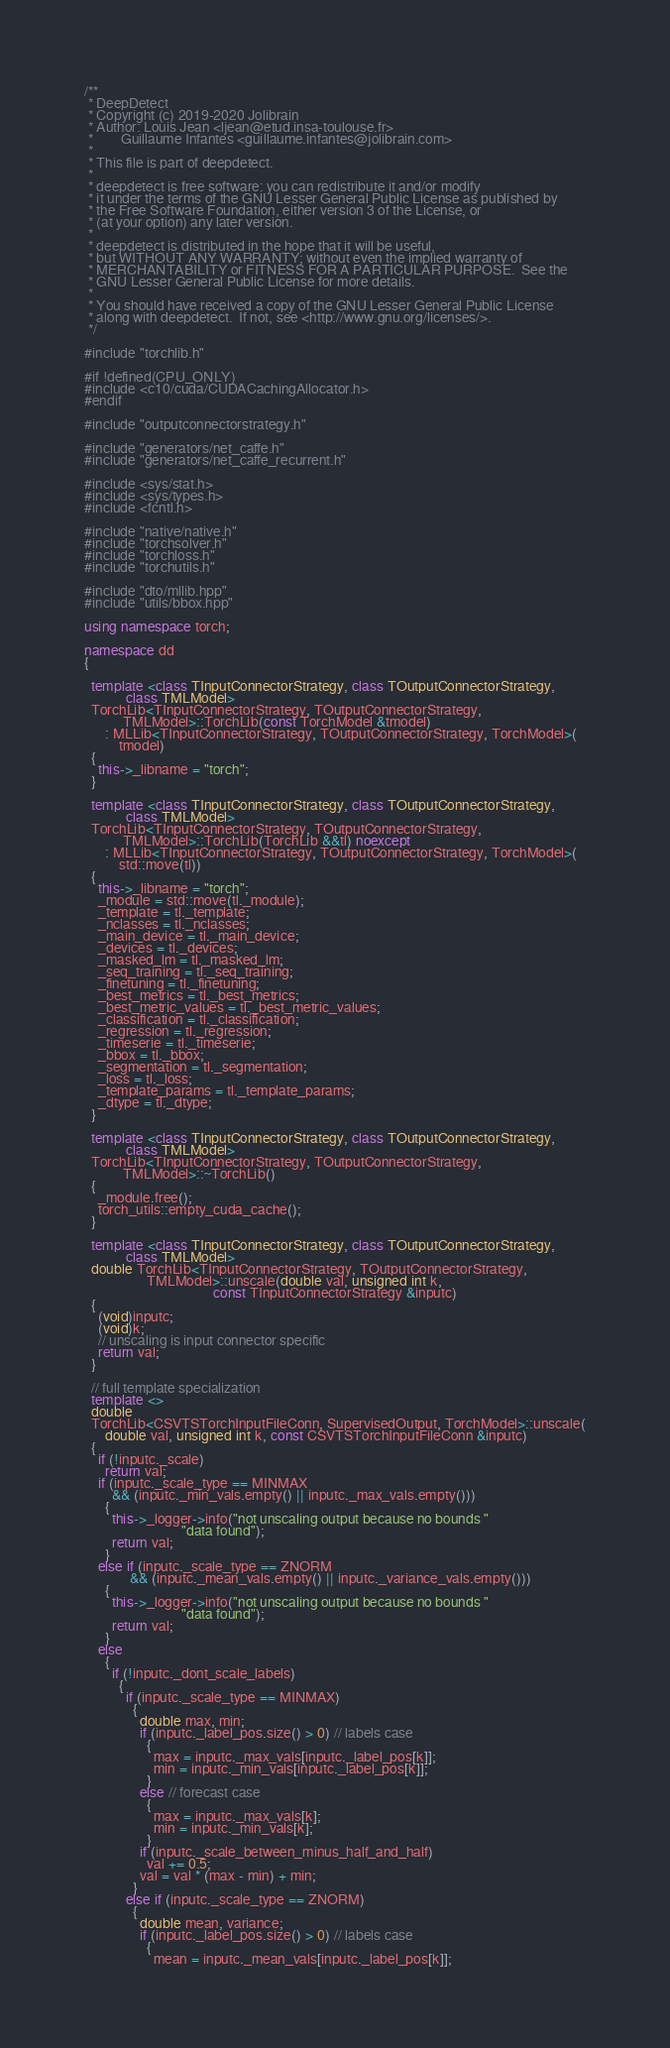Convert code to text. <code><loc_0><loc_0><loc_500><loc_500><_C++_>/**
 * DeepDetect
 * Copyright (c) 2019-2020 Jolibrain
 * Author: Louis Jean <ljean@etud.insa-toulouse.fr>
 *        Guillaume Infantes <guillaume.infantes@jolibrain.com>
 *
 * This file is part of deepdetect.
 *
 * deepdetect is free software: you can redistribute it and/or modify
 * it under the terms of the GNU Lesser General Public License as published by
 * the Free Software Foundation, either version 3 of the License, or
 * (at your option) any later version.
 *
 * deepdetect is distributed in the hope that it will be useful,
 * but WITHOUT ANY WARRANTY; without even the implied warranty of
 * MERCHANTABILITY or FITNESS FOR A PARTICULAR PURPOSE.  See the
 * GNU Lesser General Public License for more details.
 *
 * You should have received a copy of the GNU Lesser General Public License
 * along with deepdetect.  If not, see <http://www.gnu.org/licenses/>.
 */

#include "torchlib.h"

#if !defined(CPU_ONLY)
#include <c10/cuda/CUDACachingAllocator.h>
#endif

#include "outputconnectorstrategy.h"

#include "generators/net_caffe.h"
#include "generators/net_caffe_recurrent.h"

#include <sys/stat.h>
#include <sys/types.h>
#include <fcntl.h>

#include "native/native.h"
#include "torchsolver.h"
#include "torchloss.h"
#include "torchutils.h"

#include "dto/mllib.hpp"
#include "utils/bbox.hpp"

using namespace torch;

namespace dd
{

  template <class TInputConnectorStrategy, class TOutputConnectorStrategy,
            class TMLModel>
  TorchLib<TInputConnectorStrategy, TOutputConnectorStrategy,
           TMLModel>::TorchLib(const TorchModel &tmodel)
      : MLLib<TInputConnectorStrategy, TOutputConnectorStrategy, TorchModel>(
          tmodel)
  {
    this->_libname = "torch";
  }

  template <class TInputConnectorStrategy, class TOutputConnectorStrategy,
            class TMLModel>
  TorchLib<TInputConnectorStrategy, TOutputConnectorStrategy,
           TMLModel>::TorchLib(TorchLib &&tl) noexcept
      : MLLib<TInputConnectorStrategy, TOutputConnectorStrategy, TorchModel>(
          std::move(tl))
  {
    this->_libname = "torch";
    _module = std::move(tl._module);
    _template = tl._template;
    _nclasses = tl._nclasses;
    _main_device = tl._main_device;
    _devices = tl._devices;
    _masked_lm = tl._masked_lm;
    _seq_training = tl._seq_training;
    _finetuning = tl._finetuning;
    _best_metrics = tl._best_metrics;
    _best_metric_values = tl._best_metric_values;
    _classification = tl._classification;
    _regression = tl._regression;
    _timeserie = tl._timeserie;
    _bbox = tl._bbox;
    _segmentation = tl._segmentation;
    _loss = tl._loss;
    _template_params = tl._template_params;
    _dtype = tl._dtype;
  }

  template <class TInputConnectorStrategy, class TOutputConnectorStrategy,
            class TMLModel>
  TorchLib<TInputConnectorStrategy, TOutputConnectorStrategy,
           TMLModel>::~TorchLib()
  {
    _module.free();
    torch_utils::empty_cuda_cache();
  }

  template <class TInputConnectorStrategy, class TOutputConnectorStrategy,
            class TMLModel>
  double TorchLib<TInputConnectorStrategy, TOutputConnectorStrategy,
                  TMLModel>::unscale(double val, unsigned int k,
                                     const TInputConnectorStrategy &inputc)
  {
    (void)inputc;
    (void)k;
    // unscaling is input connector specific
    return val;
  }

  // full template specialization
  template <>
  double
  TorchLib<CSVTSTorchInputFileConn, SupervisedOutput, TorchModel>::unscale(
      double val, unsigned int k, const CSVTSTorchInputFileConn &inputc)
  {
    if (!inputc._scale)
      return val;
    if (inputc._scale_type == MINMAX
        && (inputc._min_vals.empty() || inputc._max_vals.empty()))
      {
        this->_logger->info("not unscaling output because no bounds "
                            "data found");
        return val;
      }
    else if (inputc._scale_type == ZNORM
             && (inputc._mean_vals.empty() || inputc._variance_vals.empty()))
      {
        this->_logger->info("not unscaling output because no bounds "
                            "data found");
        return val;
      }
    else
      {
        if (!inputc._dont_scale_labels)
          {
            if (inputc._scale_type == MINMAX)
              {
                double max, min;
                if (inputc._label_pos.size() > 0) // labels case
                  {
                    max = inputc._max_vals[inputc._label_pos[k]];
                    min = inputc._min_vals[inputc._label_pos[k]];
                  }
                else // forecast case
                  {
                    max = inputc._max_vals[k];
                    min = inputc._min_vals[k];
                  }
                if (inputc._scale_between_minus_half_and_half)
                  val += 0.5;
                val = val * (max - min) + min;
              }
            else if (inputc._scale_type == ZNORM)
              {
                double mean, variance;
                if (inputc._label_pos.size() > 0) // labels case
                  {
                    mean = inputc._mean_vals[inputc._label_pos[k]];</code> 